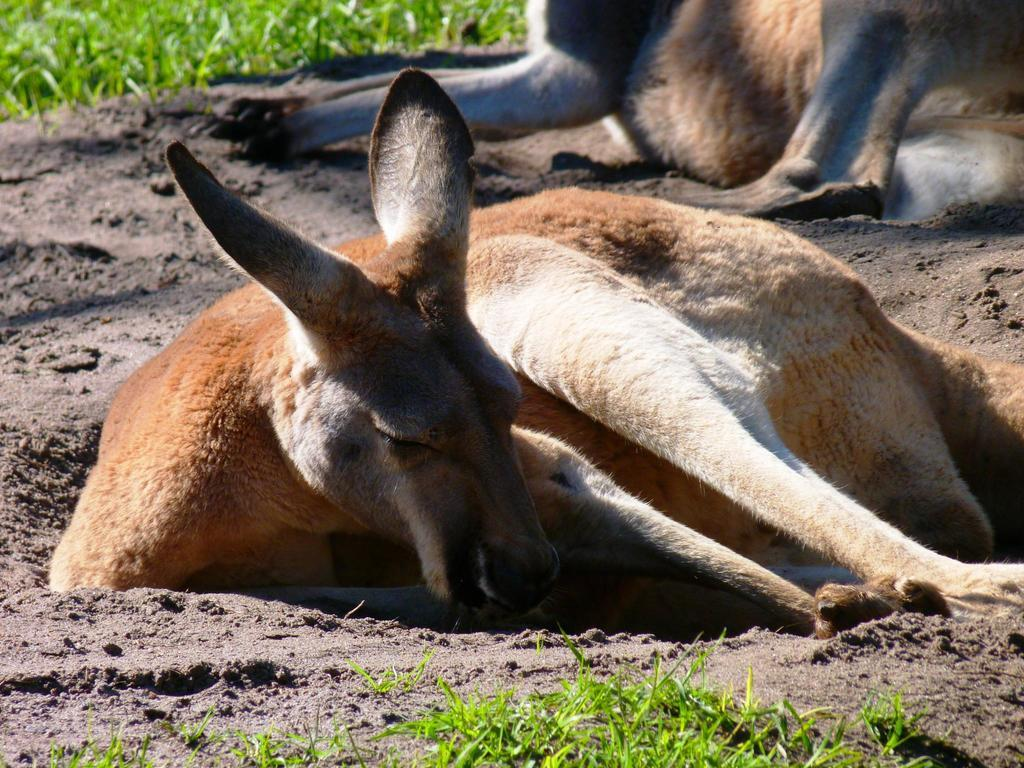How many donkeys are in the image? There are two donkeys in the image. What are the donkeys doing in the image? The donkeys are sitting on the ground. What type of vegetation can be seen at the bottom of the image? There is grass visible at the bottom of the image. What type of vegetation can be seen at the top of the image? There are plants visible at the top of the image. What type of produce is being loaded into the cannon in the image? There is no cannon or produce present in the image; it features two donkeys sitting on the ground with grass and plants visible. 